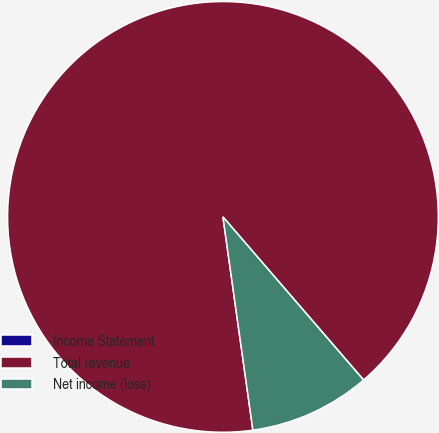<chart> <loc_0><loc_0><loc_500><loc_500><pie_chart><fcel>Income Statement<fcel>Total revenue<fcel>Net income (loss)<nl><fcel>0.01%<fcel>90.89%<fcel>9.1%<nl></chart> 